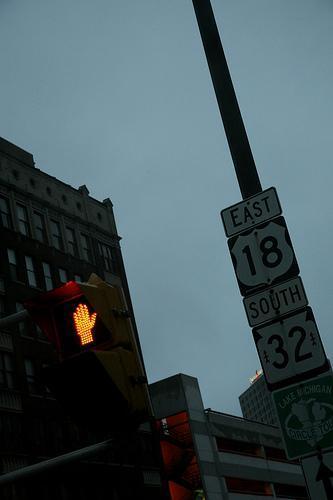How many signs are visible on a pole?
Give a very brief answer. 5. 